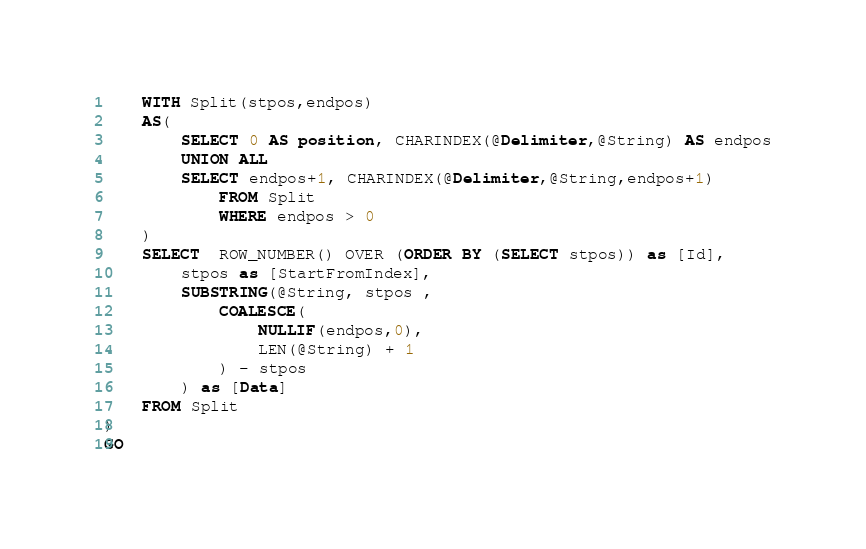<code> <loc_0><loc_0><loc_500><loc_500><_SQL_>    WITH Split(stpos,endpos)
    AS(
        SELECT 0 AS position, CHARINDEX(@Delimiter,@String) AS endpos
        UNION ALL
        SELECT endpos+1, CHARINDEX(@Delimiter,@String,endpos+1)
            FROM Split
            WHERE endpos > 0
    )
    SELECT  ROW_NUMBER() OVER (ORDER BY (SELECT stpos)) as [Id],
        stpos as [StartFromIndex],
        SUBSTRING(@String, stpos ,
            COALESCE(
                NULLIF(endpos,0),
                LEN(@String) + 1
            ) - stpos
        ) as [Data]
    FROM Split
)
GO
</code> 